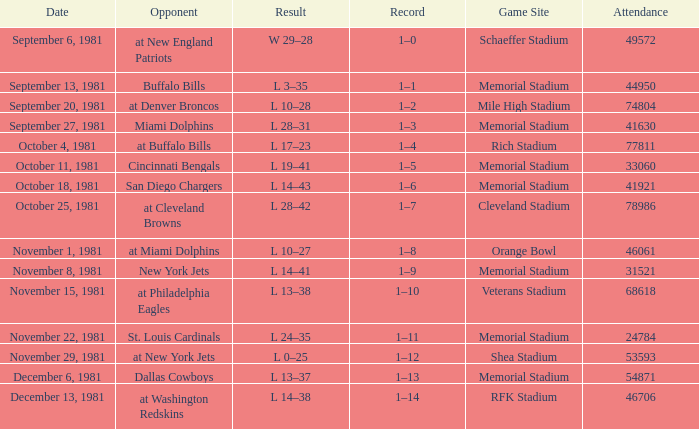Who is the rival on october 25, 1981? At cleveland browns. 